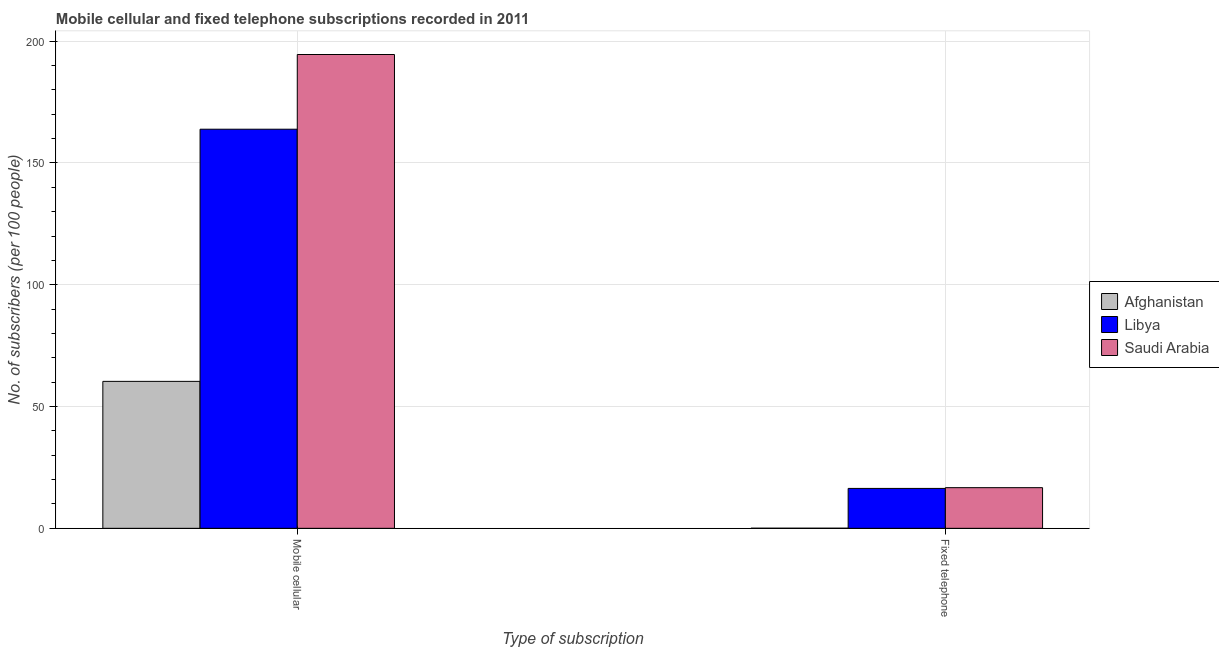How many different coloured bars are there?
Ensure brevity in your answer.  3. How many groups of bars are there?
Give a very brief answer. 2. What is the label of the 1st group of bars from the left?
Keep it short and to the point. Mobile cellular. What is the number of mobile cellular subscribers in Saudi Arabia?
Your answer should be compact. 194.51. Across all countries, what is the maximum number of mobile cellular subscribers?
Offer a terse response. 194.51. Across all countries, what is the minimum number of fixed telephone subscribers?
Your answer should be compact. 0.05. In which country was the number of fixed telephone subscribers maximum?
Your answer should be compact. Saudi Arabia. In which country was the number of mobile cellular subscribers minimum?
Provide a short and direct response. Afghanistan. What is the total number of fixed telephone subscribers in the graph?
Ensure brevity in your answer.  33.12. What is the difference between the number of mobile cellular subscribers in Saudi Arabia and that in Afghanistan?
Keep it short and to the point. 134.19. What is the difference between the number of mobile cellular subscribers in Libya and the number of fixed telephone subscribers in Saudi Arabia?
Your answer should be very brief. 147.16. What is the average number of mobile cellular subscribers per country?
Your answer should be very brief. 139.56. What is the difference between the number of fixed telephone subscribers and number of mobile cellular subscribers in Afghanistan?
Offer a very short reply. -60.28. In how many countries, is the number of mobile cellular subscribers greater than 120 ?
Your answer should be very brief. 2. What is the ratio of the number of fixed telephone subscribers in Afghanistan to that in Saudi Arabia?
Offer a terse response. 0. What does the 3rd bar from the left in Mobile cellular represents?
Provide a short and direct response. Saudi Arabia. What does the 1st bar from the right in Fixed telephone represents?
Provide a succinct answer. Saudi Arabia. How many countries are there in the graph?
Offer a very short reply. 3. Are the values on the major ticks of Y-axis written in scientific E-notation?
Give a very brief answer. No. Does the graph contain grids?
Your answer should be very brief. Yes. Where does the legend appear in the graph?
Keep it short and to the point. Center right. How are the legend labels stacked?
Provide a short and direct response. Vertical. What is the title of the graph?
Your answer should be compact. Mobile cellular and fixed telephone subscriptions recorded in 2011. What is the label or title of the X-axis?
Provide a succinct answer. Type of subscription. What is the label or title of the Y-axis?
Ensure brevity in your answer.  No. of subscribers (per 100 people). What is the No. of subscribers (per 100 people) of Afghanistan in Mobile cellular?
Offer a terse response. 60.33. What is the No. of subscribers (per 100 people) in Libya in Mobile cellular?
Give a very brief answer. 163.85. What is the No. of subscribers (per 100 people) of Saudi Arabia in Mobile cellular?
Offer a very short reply. 194.51. What is the No. of subscribers (per 100 people) of Afghanistan in Fixed telephone?
Keep it short and to the point. 0.05. What is the No. of subscribers (per 100 people) in Libya in Fixed telephone?
Provide a short and direct response. 16.38. What is the No. of subscribers (per 100 people) in Saudi Arabia in Fixed telephone?
Keep it short and to the point. 16.69. Across all Type of subscription, what is the maximum No. of subscribers (per 100 people) in Afghanistan?
Keep it short and to the point. 60.33. Across all Type of subscription, what is the maximum No. of subscribers (per 100 people) of Libya?
Your answer should be very brief. 163.85. Across all Type of subscription, what is the maximum No. of subscribers (per 100 people) of Saudi Arabia?
Your answer should be compact. 194.51. Across all Type of subscription, what is the minimum No. of subscribers (per 100 people) of Afghanistan?
Your response must be concise. 0.05. Across all Type of subscription, what is the minimum No. of subscribers (per 100 people) in Libya?
Provide a short and direct response. 16.38. Across all Type of subscription, what is the minimum No. of subscribers (per 100 people) in Saudi Arabia?
Make the answer very short. 16.69. What is the total No. of subscribers (per 100 people) in Afghanistan in the graph?
Keep it short and to the point. 60.37. What is the total No. of subscribers (per 100 people) of Libya in the graph?
Offer a very short reply. 180.23. What is the total No. of subscribers (per 100 people) of Saudi Arabia in the graph?
Keep it short and to the point. 211.2. What is the difference between the No. of subscribers (per 100 people) in Afghanistan in Mobile cellular and that in Fixed telephone?
Make the answer very short. 60.28. What is the difference between the No. of subscribers (per 100 people) of Libya in Mobile cellular and that in Fixed telephone?
Give a very brief answer. 147.46. What is the difference between the No. of subscribers (per 100 people) in Saudi Arabia in Mobile cellular and that in Fixed telephone?
Your answer should be compact. 177.82. What is the difference between the No. of subscribers (per 100 people) of Afghanistan in Mobile cellular and the No. of subscribers (per 100 people) of Libya in Fixed telephone?
Keep it short and to the point. 43.94. What is the difference between the No. of subscribers (per 100 people) in Afghanistan in Mobile cellular and the No. of subscribers (per 100 people) in Saudi Arabia in Fixed telephone?
Keep it short and to the point. 43.64. What is the difference between the No. of subscribers (per 100 people) in Libya in Mobile cellular and the No. of subscribers (per 100 people) in Saudi Arabia in Fixed telephone?
Provide a short and direct response. 147.16. What is the average No. of subscribers (per 100 people) in Afghanistan per Type of subscription?
Your response must be concise. 30.19. What is the average No. of subscribers (per 100 people) in Libya per Type of subscription?
Give a very brief answer. 90.12. What is the average No. of subscribers (per 100 people) in Saudi Arabia per Type of subscription?
Your answer should be compact. 105.6. What is the difference between the No. of subscribers (per 100 people) of Afghanistan and No. of subscribers (per 100 people) of Libya in Mobile cellular?
Your response must be concise. -103.52. What is the difference between the No. of subscribers (per 100 people) in Afghanistan and No. of subscribers (per 100 people) in Saudi Arabia in Mobile cellular?
Keep it short and to the point. -134.19. What is the difference between the No. of subscribers (per 100 people) in Libya and No. of subscribers (per 100 people) in Saudi Arabia in Mobile cellular?
Offer a terse response. -30.66. What is the difference between the No. of subscribers (per 100 people) of Afghanistan and No. of subscribers (per 100 people) of Libya in Fixed telephone?
Your response must be concise. -16.34. What is the difference between the No. of subscribers (per 100 people) in Afghanistan and No. of subscribers (per 100 people) in Saudi Arabia in Fixed telephone?
Ensure brevity in your answer.  -16.64. What is the difference between the No. of subscribers (per 100 people) of Libya and No. of subscribers (per 100 people) of Saudi Arabia in Fixed telephone?
Offer a terse response. -0.3. What is the ratio of the No. of subscribers (per 100 people) in Afghanistan in Mobile cellular to that in Fixed telephone?
Offer a very short reply. 1299.75. What is the ratio of the No. of subscribers (per 100 people) in Libya in Mobile cellular to that in Fixed telephone?
Your answer should be very brief. 10. What is the ratio of the No. of subscribers (per 100 people) in Saudi Arabia in Mobile cellular to that in Fixed telephone?
Offer a very short reply. 11.66. What is the difference between the highest and the second highest No. of subscribers (per 100 people) in Afghanistan?
Your answer should be compact. 60.28. What is the difference between the highest and the second highest No. of subscribers (per 100 people) of Libya?
Ensure brevity in your answer.  147.46. What is the difference between the highest and the second highest No. of subscribers (per 100 people) of Saudi Arabia?
Offer a terse response. 177.82. What is the difference between the highest and the lowest No. of subscribers (per 100 people) of Afghanistan?
Offer a terse response. 60.28. What is the difference between the highest and the lowest No. of subscribers (per 100 people) in Libya?
Your answer should be compact. 147.46. What is the difference between the highest and the lowest No. of subscribers (per 100 people) of Saudi Arabia?
Keep it short and to the point. 177.82. 